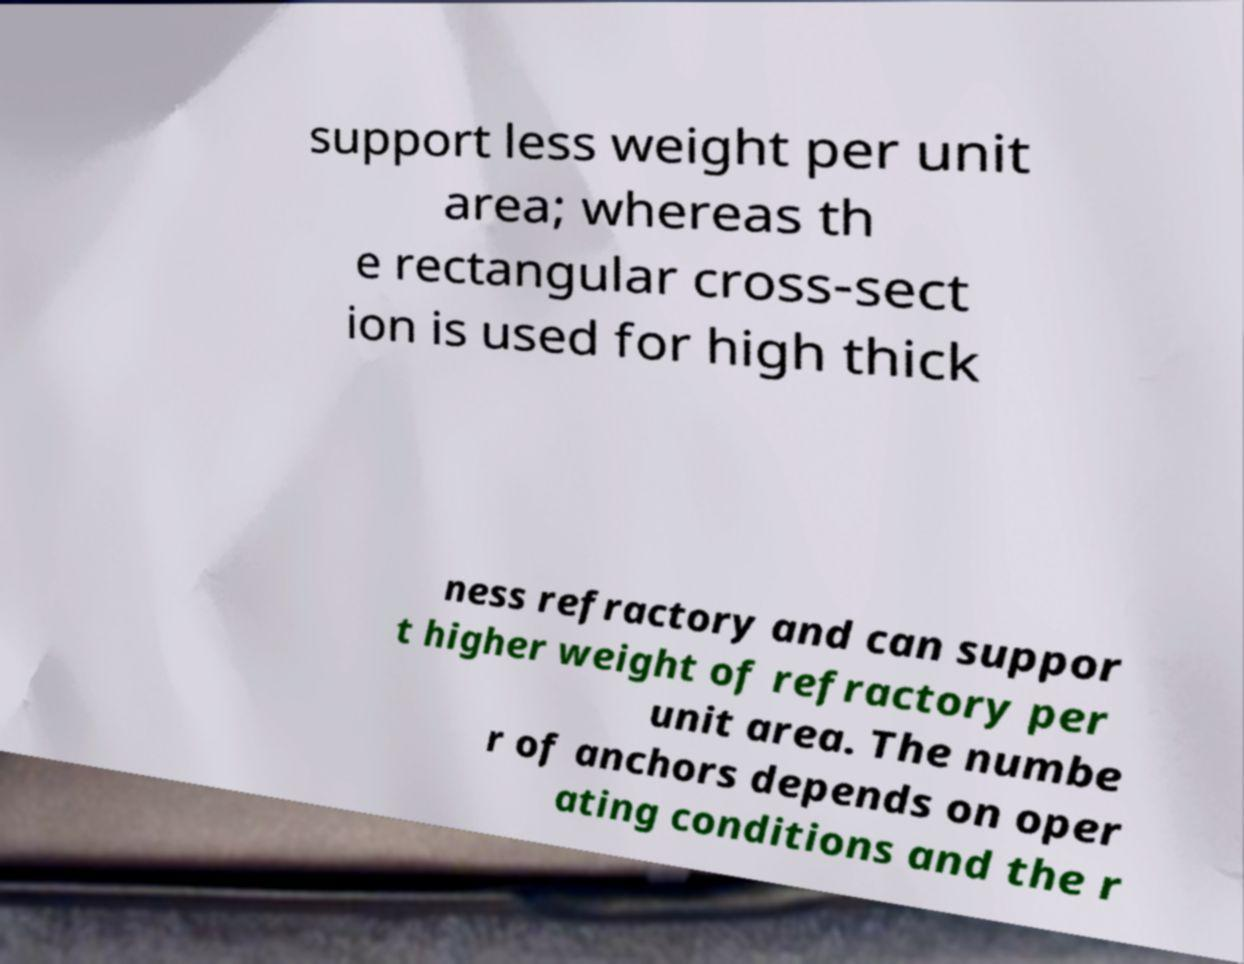I need the written content from this picture converted into text. Can you do that? support less weight per unit area; whereas th e rectangular cross-sect ion is used for high thick ness refractory and can suppor t higher weight of refractory per unit area. The numbe r of anchors depends on oper ating conditions and the r 